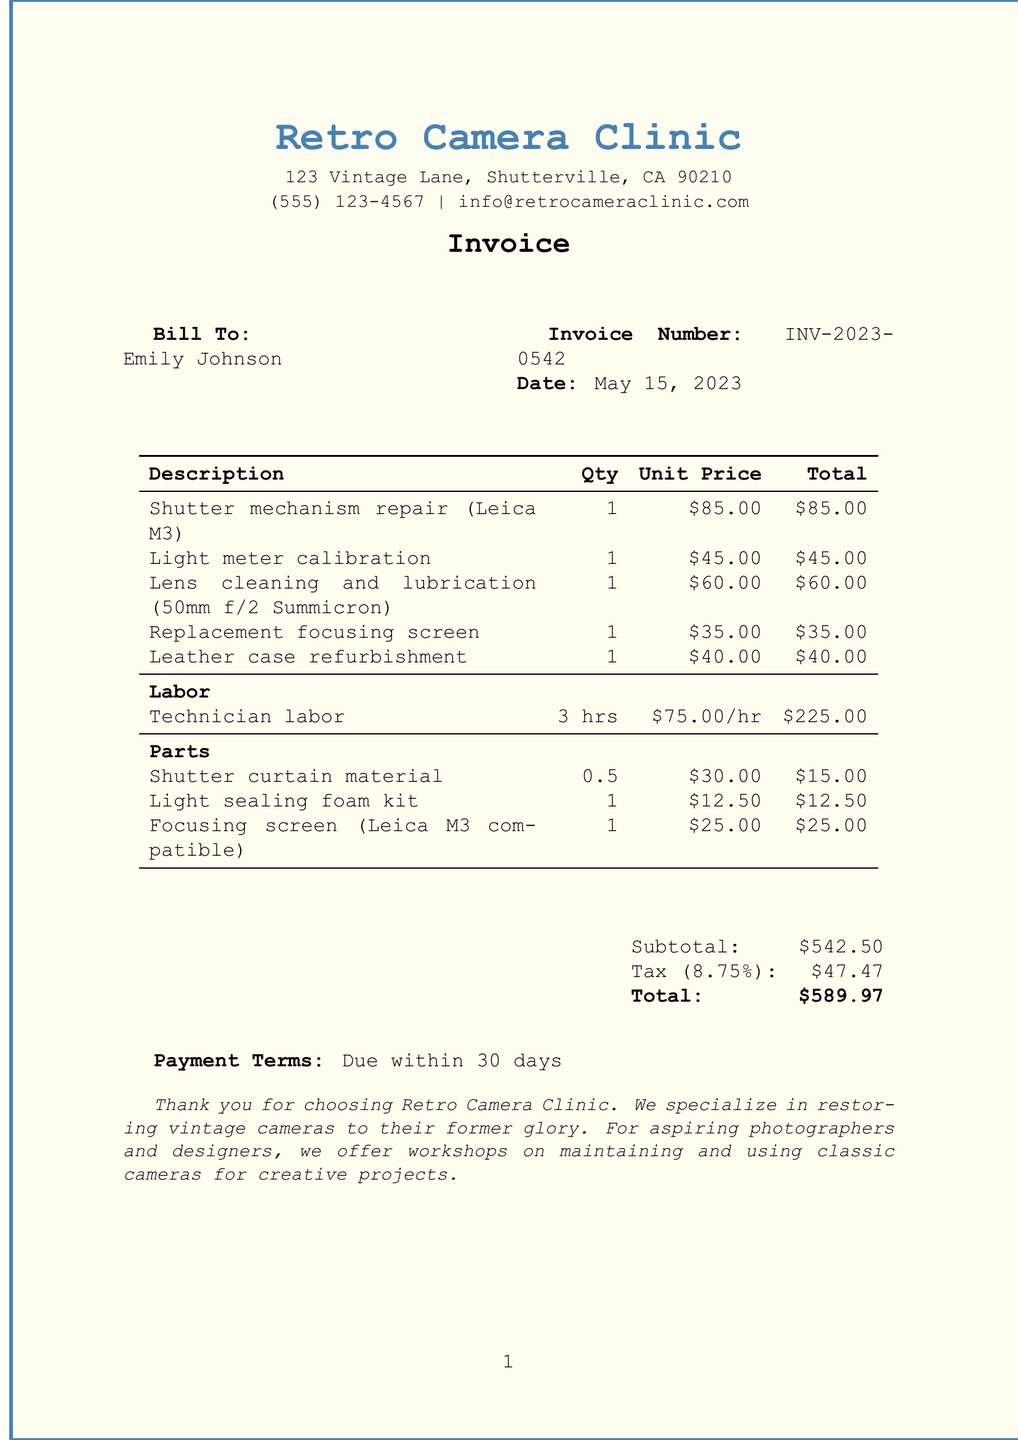What is the business name? The business name is listed at the top of the document.
Answer: Retro Camera Clinic Who is the customer? The customer's name is found under the "Bill To" section.
Answer: Emily Johnson What is the invoice number? The invoice number is specified in the document near the date.
Answer: INV-2023-0542 What date is listed on the invoice? The date of the invoice is indicated prominently in the document.
Answer: May 15, 2023 What was the total for labor? The total for labor is calculated and shown in the table for services.
Answer: $225.00 How many hours of labor were charged? The labor section specifies the number of hours worked by the technician.
Answer: 3 hours What is the subtotal before tax? The subtotal is calculated from all itemized costs before applying tax.
Answer: $542.50 What is the tax rate applied? The tax rate can be found next to the tax amount section.
Answer: 8.75% What is the total amount due? The total amount is provided at the bottom of the invoice, summarizing all costs.
Answer: $589.97 